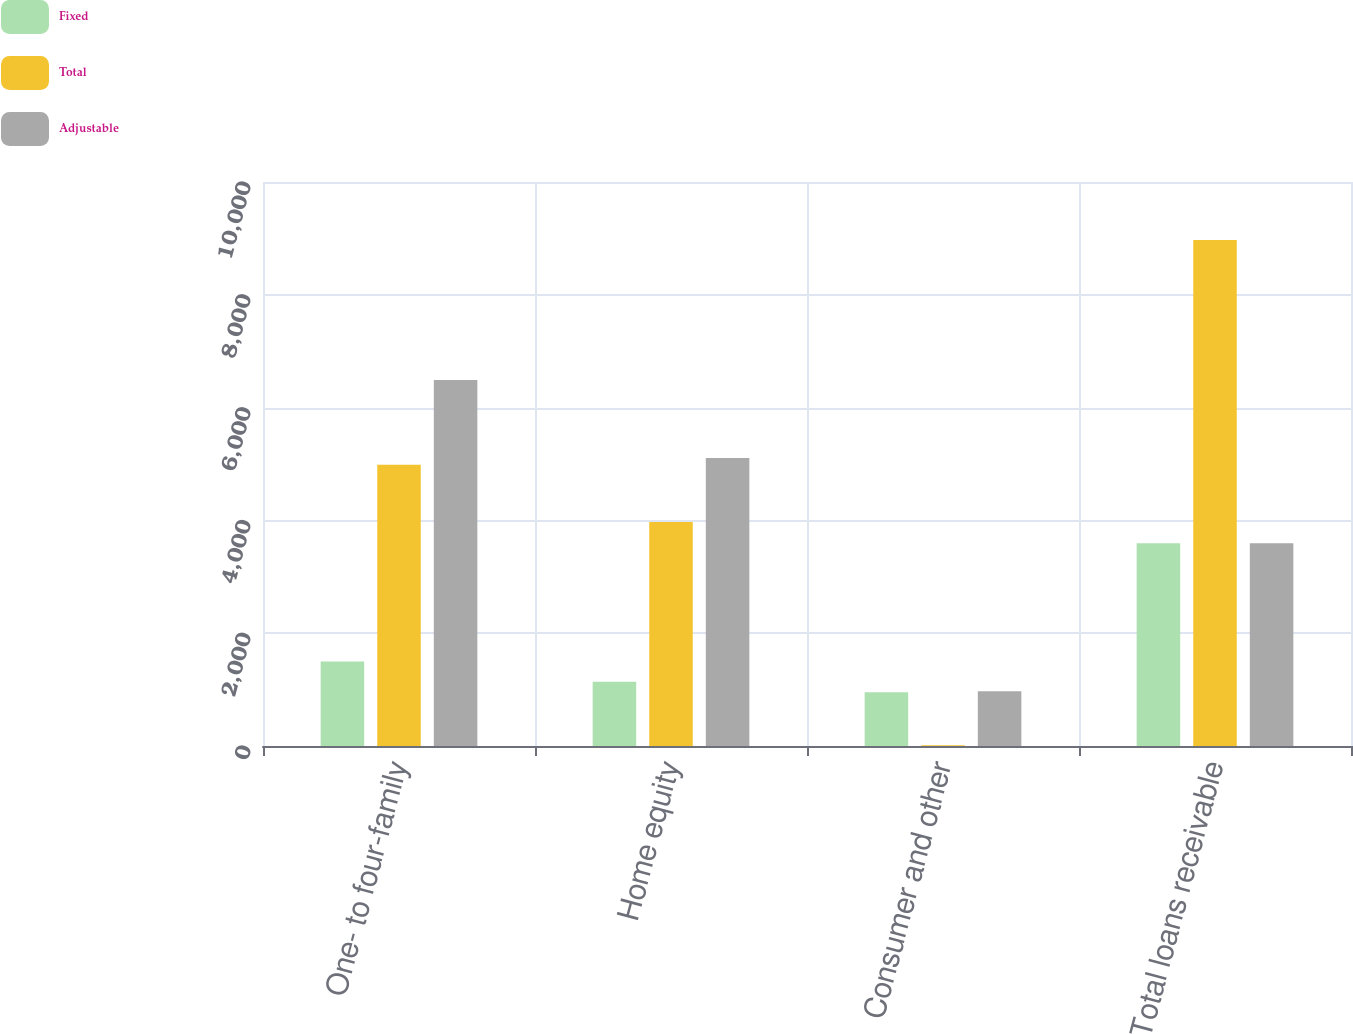Convert chart to OTSL. <chart><loc_0><loc_0><loc_500><loc_500><stacked_bar_chart><ecel><fcel>One- to four-family<fcel>Home equity<fcel>Consumer and other<fcel>Total loans receivable<nl><fcel>Fixed<fcel>1500.2<fcel>1138<fcel>954.9<fcel>3593.1<nl><fcel>Total<fcel>4988.5<fcel>3969.8<fcel>13.9<fcel>8972.2<nl><fcel>Adjustable<fcel>6488.7<fcel>5107.8<fcel>968.8<fcel>3593.1<nl></chart> 